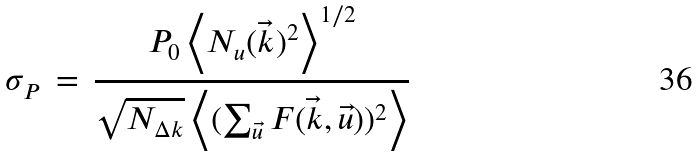Convert formula to latex. <formula><loc_0><loc_0><loc_500><loc_500>\sigma _ { P } \, = \, \frac { P _ { 0 } \left \langle N _ { u } ( \vec { k } ) ^ { 2 } \right \rangle ^ { 1 / 2 } } { \sqrt { N _ { \Delta k } } \left \langle ( \sum _ { \vec { u } } F ( \vec { k } , \vec { u } ) ) ^ { 2 } \right \rangle }</formula> 